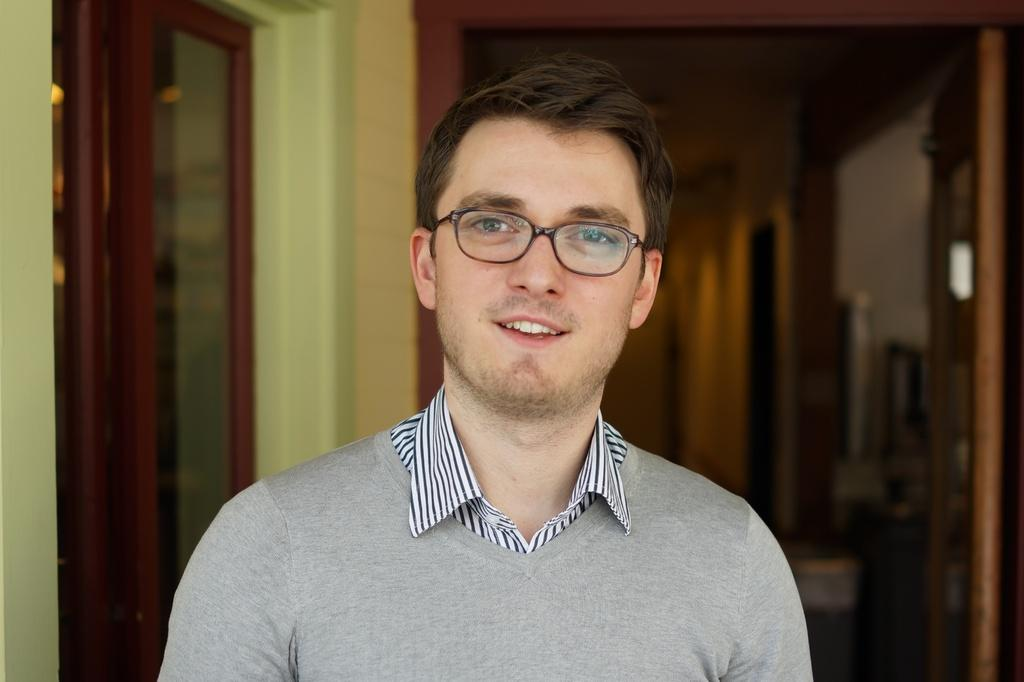What is the main subject of the image? There is a person standing in the image. Can you describe the background of the image? There is a door behind the person and a window on the left side of the image. What type of bat can be seen flying through the window in the image? There is no bat visible in the image; only a person standing and a window are present. 